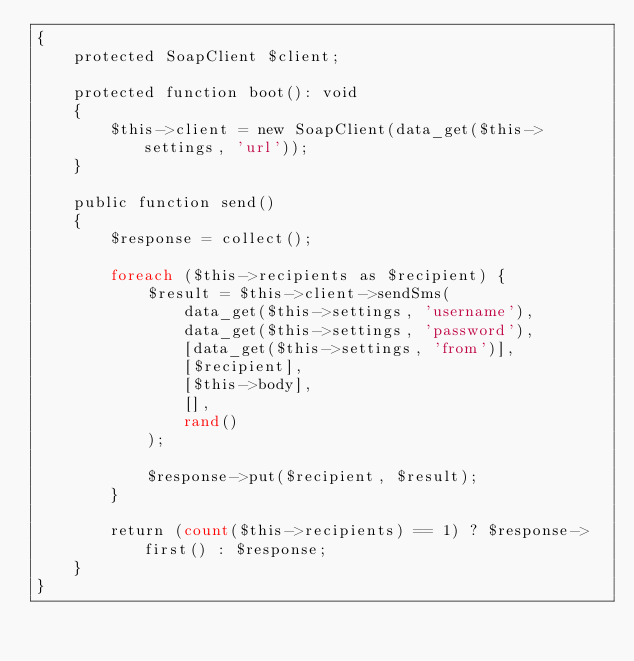<code> <loc_0><loc_0><loc_500><loc_500><_PHP_>{
    protected SoapClient $client;

    protected function boot(): void
    {
        $this->client = new SoapClient(data_get($this->settings, 'url'));
    }

    public function send()
    {
        $response = collect();

        foreach ($this->recipients as $recipient) {
            $result = $this->client->sendSms(
                data_get($this->settings, 'username'),
                data_get($this->settings, 'password'),
                [data_get($this->settings, 'from')],
                [$recipient],
                [$this->body],
                [],
                rand()
            );

            $response->put($recipient, $result);
        }

        return (count($this->recipients) == 1) ? $response->first() : $response;
    }
}
</code> 